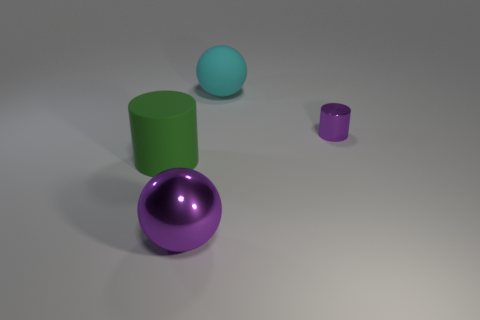Add 4 large purple shiny things. How many objects exist? 8 Add 2 large purple metal spheres. How many large purple metal spheres exist? 3 Subtract 0 green spheres. How many objects are left? 4 Subtract all small purple metal objects. Subtract all large shiny balls. How many objects are left? 2 Add 2 metal balls. How many metal balls are left? 3 